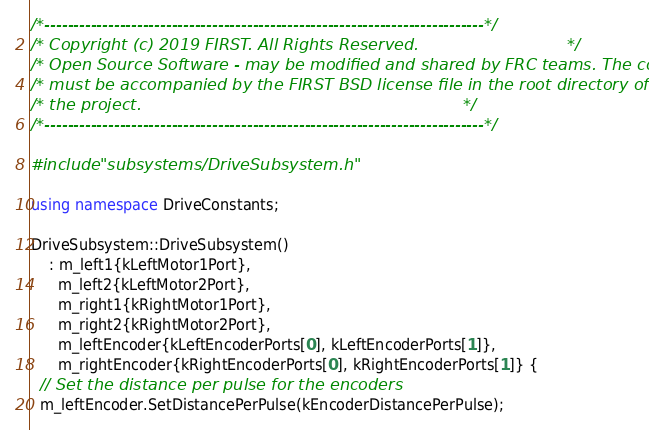Convert code to text. <code><loc_0><loc_0><loc_500><loc_500><_C++_>/*----------------------------------------------------------------------------*/
/* Copyright (c) 2019 FIRST. All Rights Reserved.                             */
/* Open Source Software - may be modified and shared by FRC teams. The code   */
/* must be accompanied by the FIRST BSD license file in the root directory of */
/* the project.                                                               */
/*----------------------------------------------------------------------------*/

#include "subsystems/DriveSubsystem.h"

using namespace DriveConstants;

DriveSubsystem::DriveSubsystem()
    : m_left1{kLeftMotor1Port},
      m_left2{kLeftMotor2Port},
      m_right1{kRightMotor1Port},
      m_right2{kRightMotor2Port},
      m_leftEncoder{kLeftEncoderPorts[0], kLeftEncoderPorts[1]},
      m_rightEncoder{kRightEncoderPorts[0], kRightEncoderPorts[1]} {
  // Set the distance per pulse for the encoders
  m_leftEncoder.SetDistancePerPulse(kEncoderDistancePerPulse);</code> 